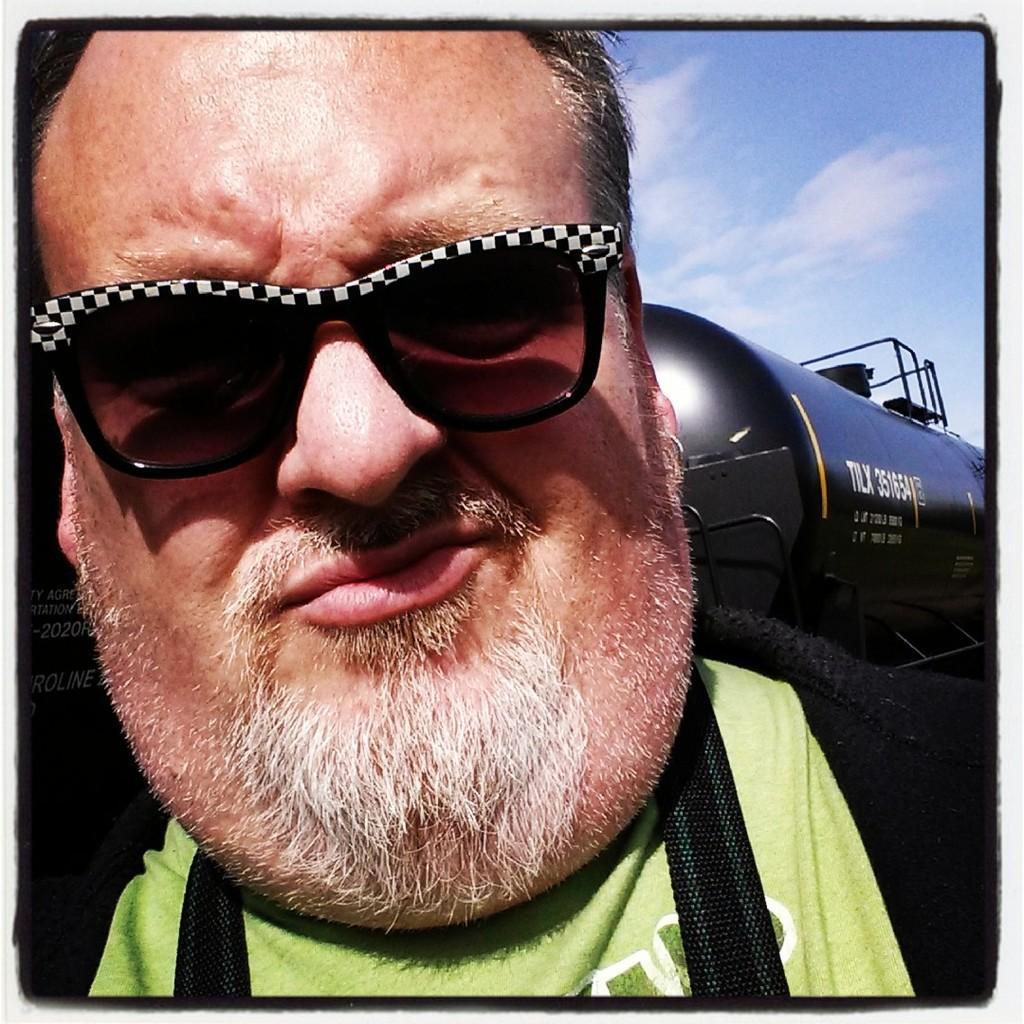Could you give a brief overview of what you see in this image? This image consists of a person in the front. Only his face is visible. He is wearing goggles. There is sky at the top. 